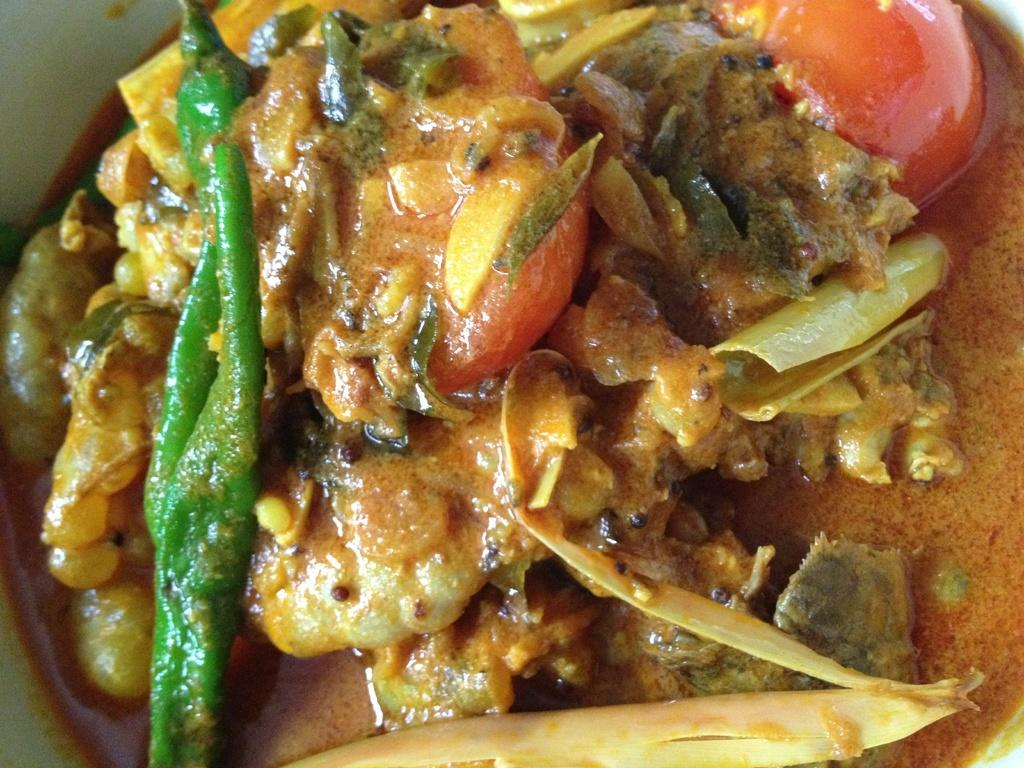What is in the bowl that is visible in the image? There is a dish in the bowl. What type of food is in the dish? The dish contains tomatoes, green chili, and other vegetables. What can be inferred about the dish from the image? The dish appears to be a recipe, possibly a vegetable dish or a salsa. What songs are being sung by the vegetables in the image? There are no songs being sung by the vegetables in the image, as vegetables do not have the ability to sing. 